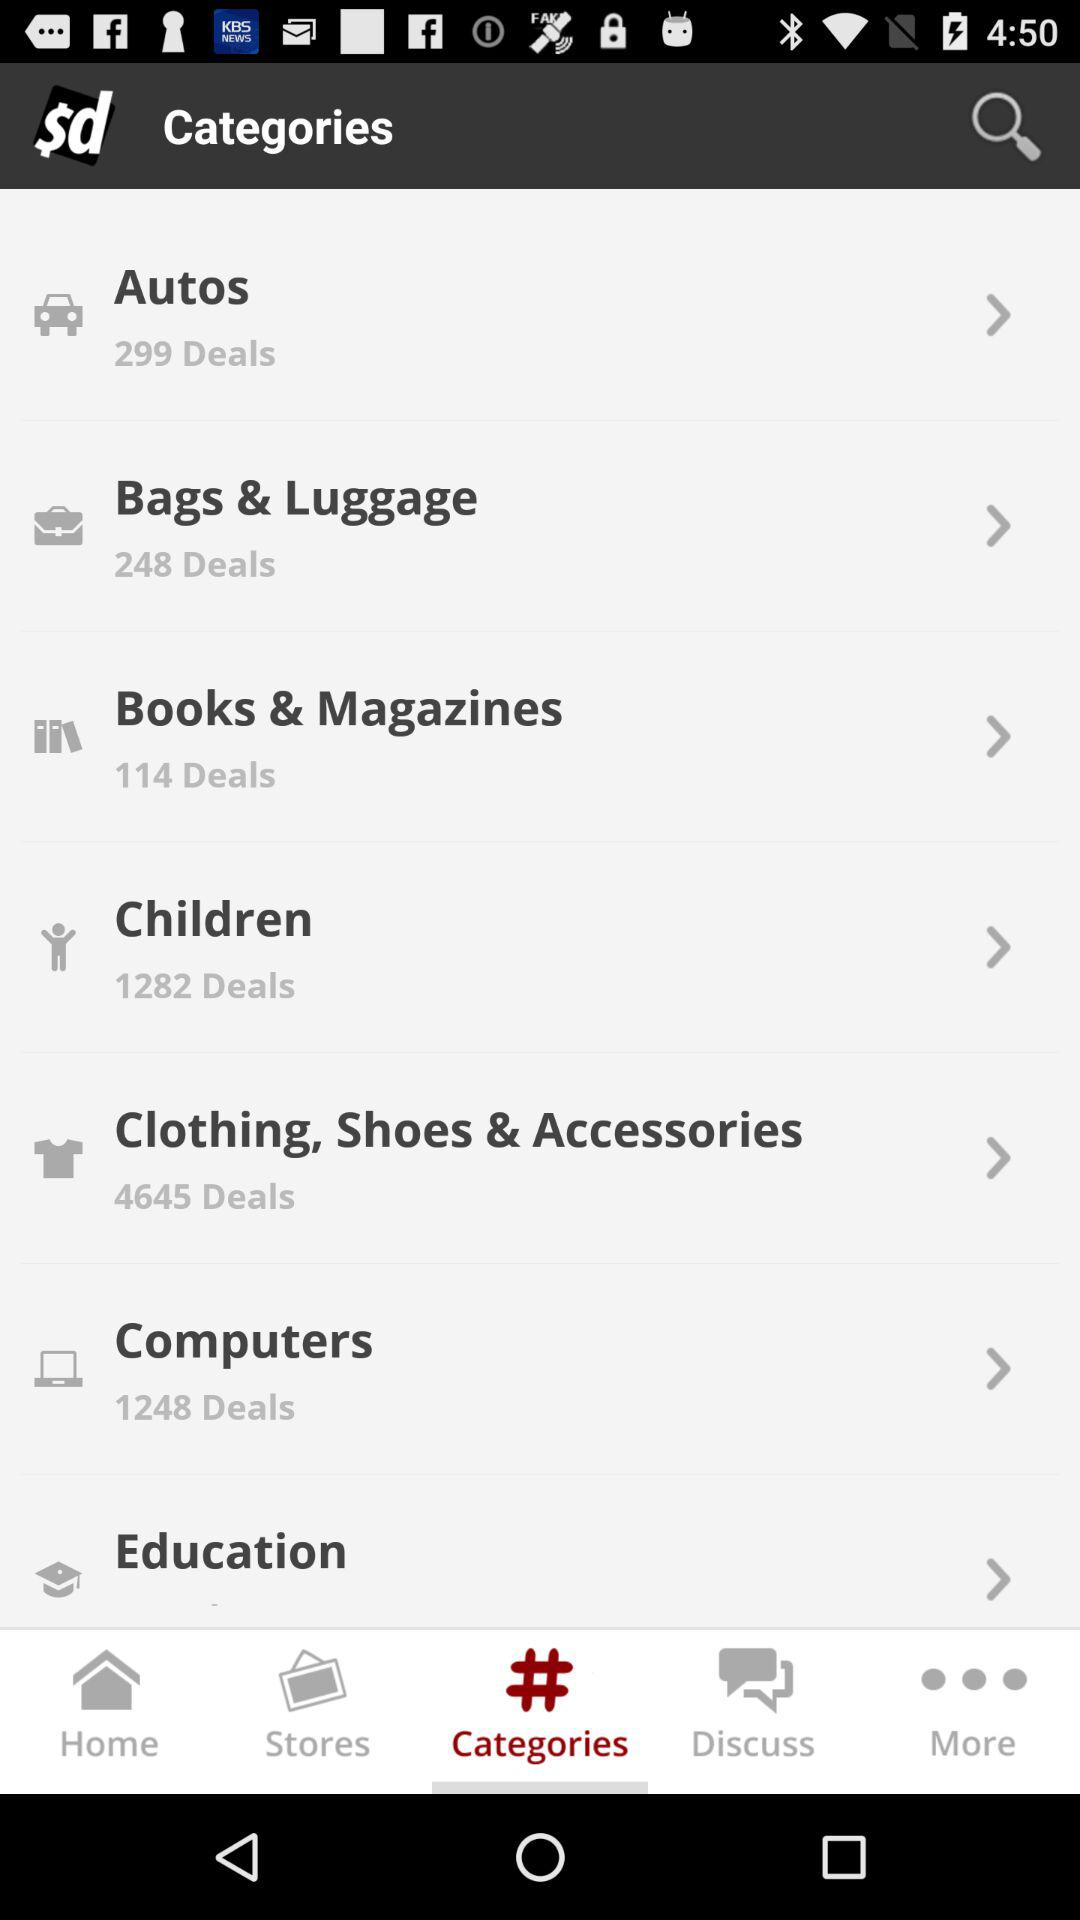What is the selected tab? The selected tab is "Categories". 